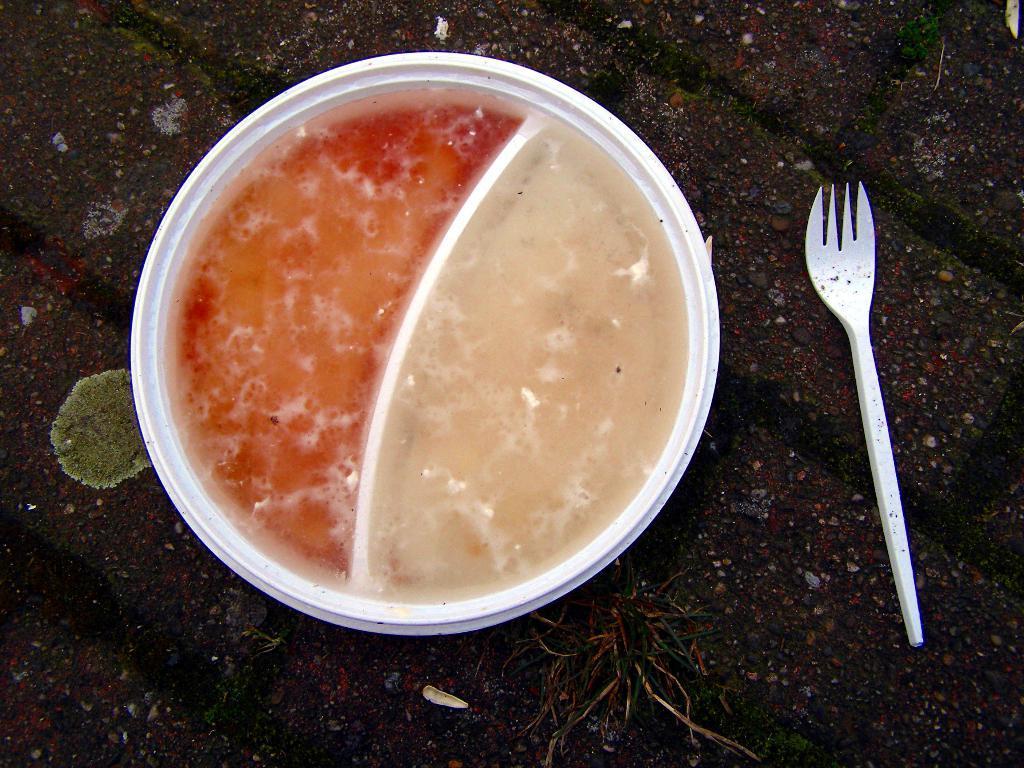How would you summarize this image in a sentence or two? We can see in the image there is a surface of the road on which a white box is kept and the white box is divided into two parts. It is filled with soups, in soup is of red colour another soup is of cream colour and there is a fork kept beside it. 